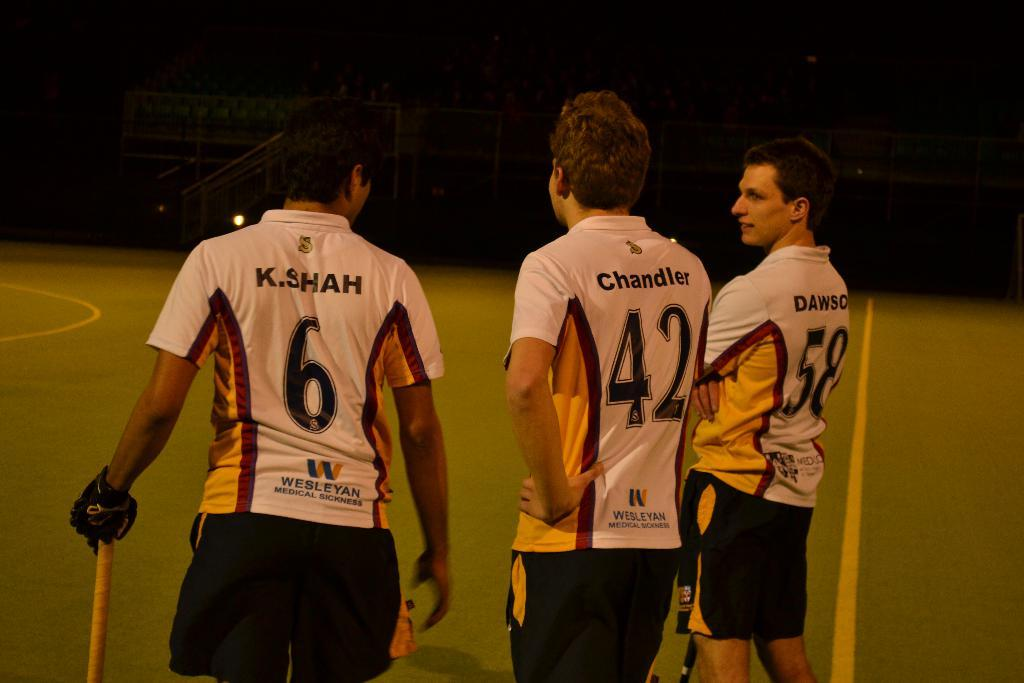Provide a one-sentence caption for the provided image. Three sports players sponsored by Wesleyan Medical Sickness. 